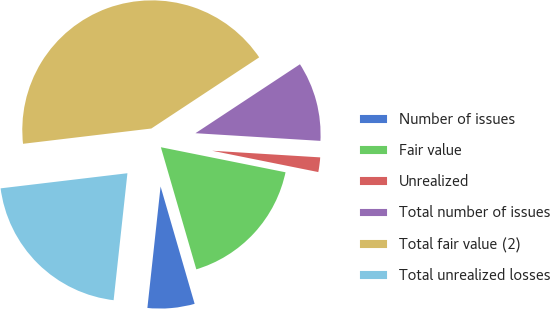<chart> <loc_0><loc_0><loc_500><loc_500><pie_chart><fcel>Number of issues<fcel>Fair value<fcel>Unrealized<fcel>Total number of issues<fcel>Total fair value (2)<fcel>Total unrealized losses<nl><fcel>6.22%<fcel>17.35%<fcel>2.18%<fcel>10.26%<fcel>42.61%<fcel>21.39%<nl></chart> 